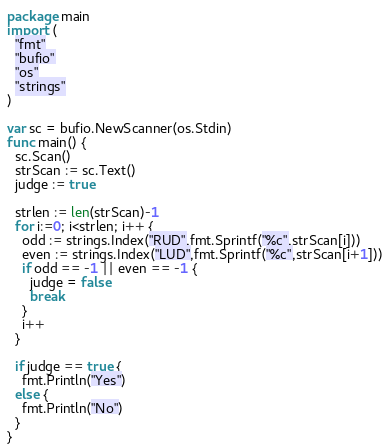Convert code to text. <code><loc_0><loc_0><loc_500><loc_500><_Go_>package main
import (
  "fmt"
  "bufio"
  "os"
  "strings"
)

var sc = bufio.NewScanner(os.Stdin)
func main() {
  sc.Scan()
  strScan := sc.Text()
  judge := true
  
  strlen := len(strScan)-1
  for i:=0; i<strlen; i++ {
    odd := strings.Index("RUD",fmt.Sprintf("%c",strScan[i]))
    even := strings.Index("LUD",fmt.Sprintf("%c",strScan[i+1]))
    if odd == -1 || even == -1 { 
      judge = false 
      break 
    }
    i++
  }
  
  if judge == true {
    fmt.Println("Yes")
  else { 
    fmt.Println("No")
  }
}</code> 